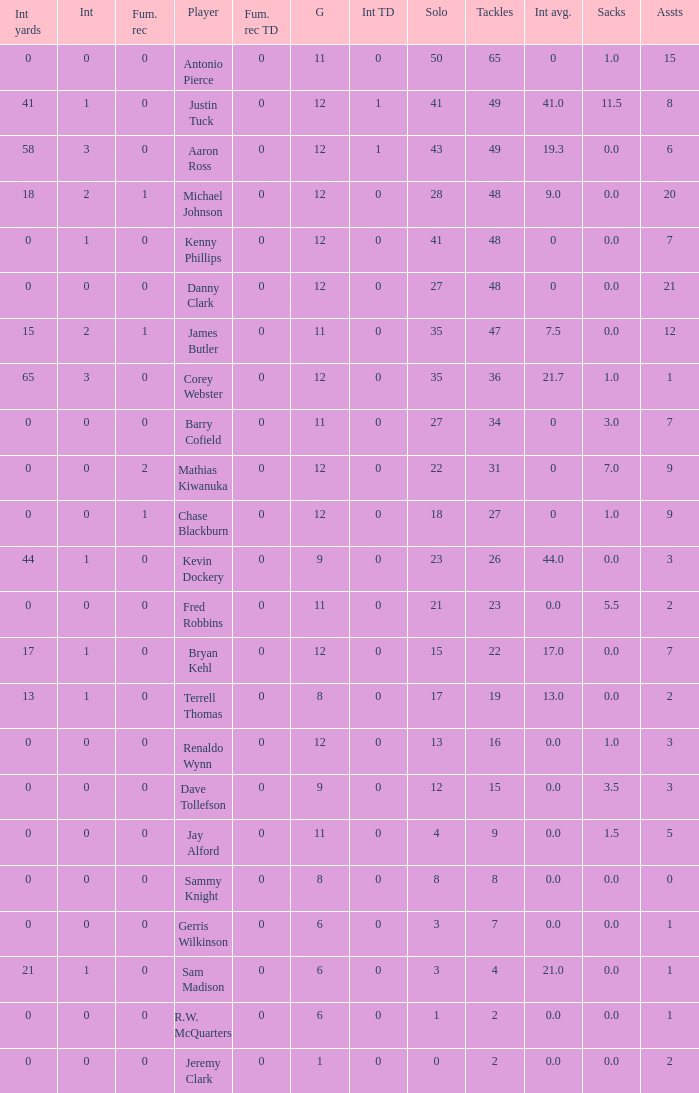Name the least int yards when sacks is 11.5 41.0. 